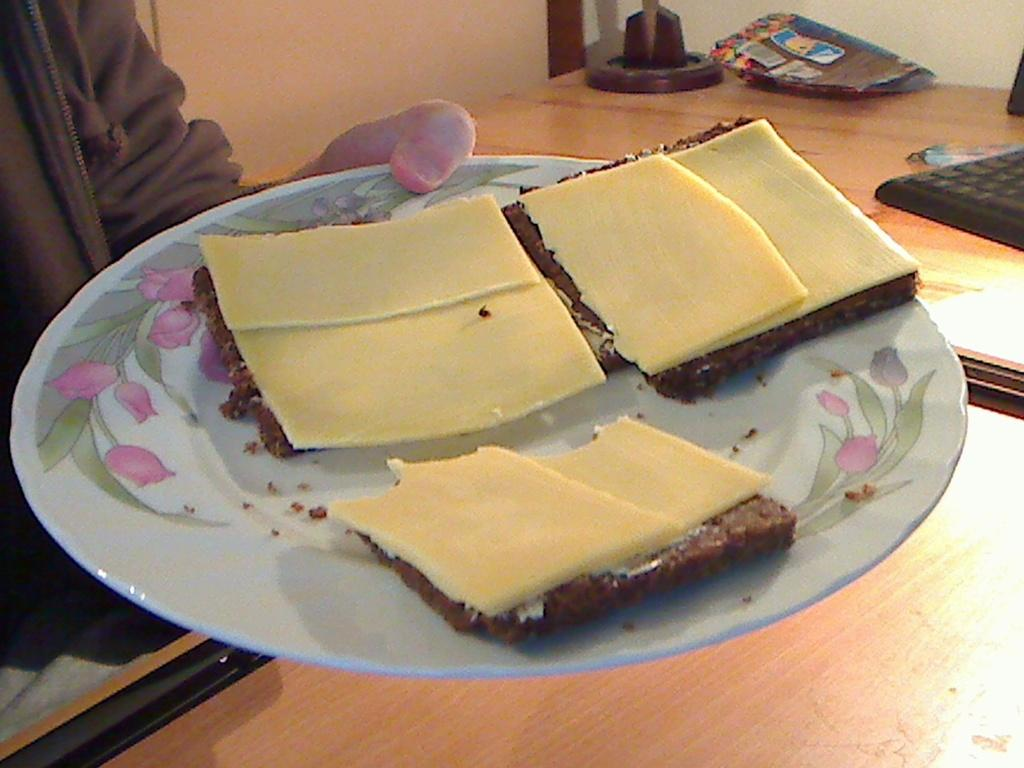What is placed on the plate in the image? There is an eatable item placed on a plate in the image. Who is holding the plate in the image? The plate is being held by a person. What is in front of the person holding the plate? There is a table in front of the person. What can be seen on the table in the image? There are objects placed on the table. Can you see any oil spills in the harbor in the image? There is no harbor or oil spills present in the image. How many times does the person kick the ball in the image? There is no ball or kicking activity present in the image. 